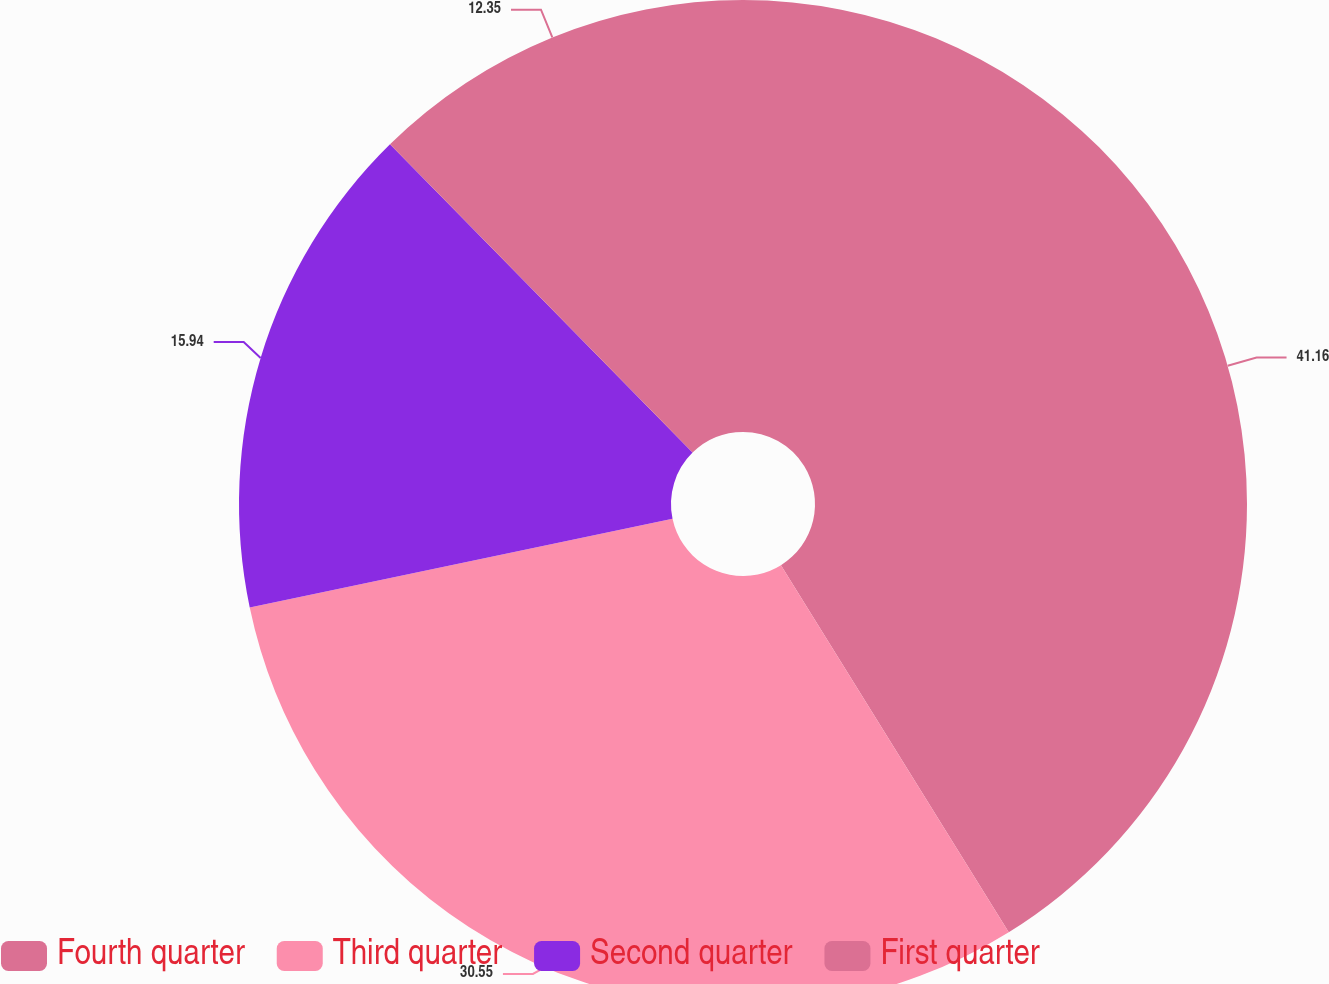<chart> <loc_0><loc_0><loc_500><loc_500><pie_chart><fcel>Fourth quarter<fcel>Third quarter<fcel>Second quarter<fcel>First quarter<nl><fcel>41.16%<fcel>30.55%<fcel>15.94%<fcel>12.35%<nl></chart> 